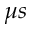<formula> <loc_0><loc_0><loc_500><loc_500>\mu s</formula> 